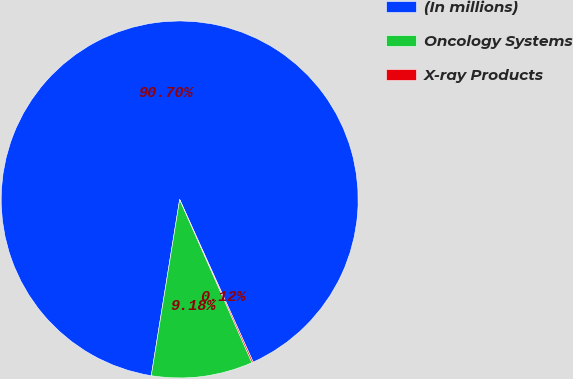Convert chart. <chart><loc_0><loc_0><loc_500><loc_500><pie_chart><fcel>(In millions)<fcel>Oncology Systems<fcel>X-ray Products<nl><fcel>90.7%<fcel>9.18%<fcel>0.12%<nl></chart> 